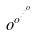<formula> <loc_0><loc_0><loc_500><loc_500>o ^ { o ^ { \cdot ^ { \cdot ^ { \cdot ^ { o } } } } }</formula> 